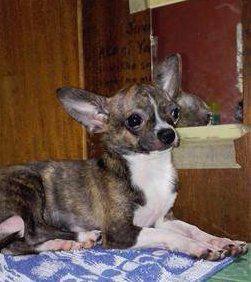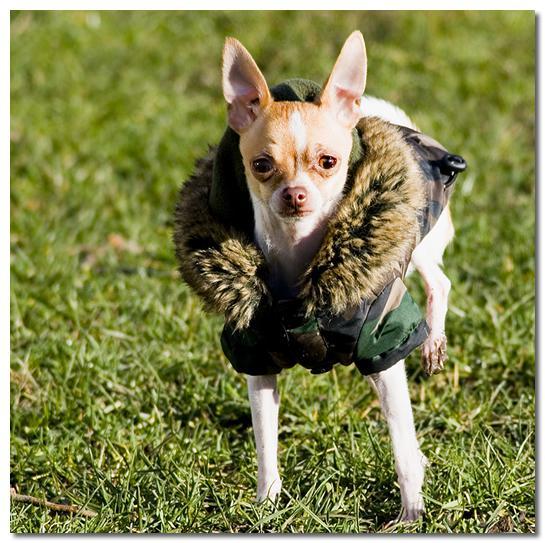The first image is the image on the left, the second image is the image on the right. Considering the images on both sides, is "All chihuahuas are shown posed on green grass, and one chihuahua has its head pointed downward toward something green." valid? Answer yes or no. No. The first image is the image on the left, the second image is the image on the right. Considering the images on both sides, is "The dog in the image on the left is lying on the grass." valid? Answer yes or no. No. 